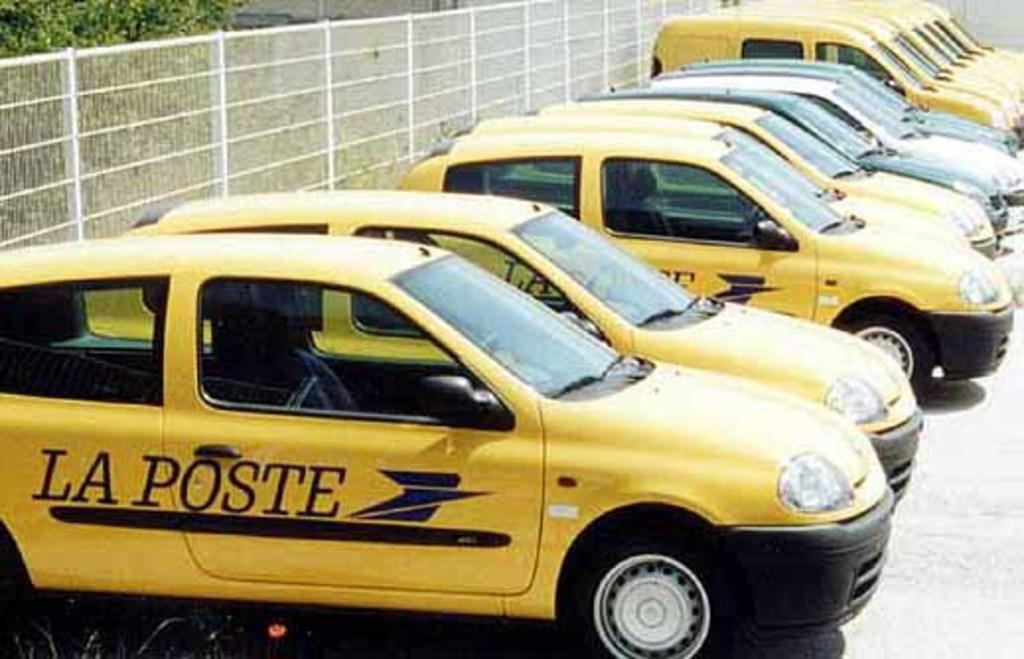Provide a one-sentence caption for the provided image. Yellow La Poste taxi cabs parked next to one another. 